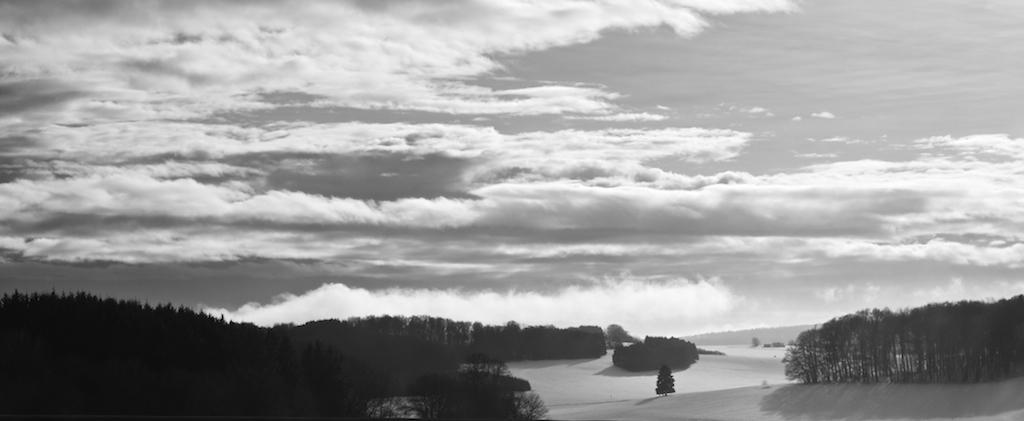How would you summarize this image in a sentence or two? This picture is clicked outside the city. In the foreground we can see the trees and the ground. In the background there is a sky which is full of clouds. 